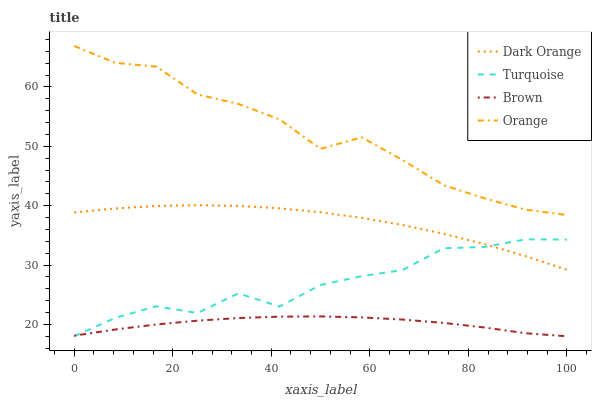Does Brown have the minimum area under the curve?
Answer yes or no. Yes. Does Orange have the maximum area under the curve?
Answer yes or no. Yes. Does Dark Orange have the minimum area under the curve?
Answer yes or no. No. Does Dark Orange have the maximum area under the curve?
Answer yes or no. No. Is Brown the smoothest?
Answer yes or no. Yes. Is Turquoise the roughest?
Answer yes or no. Yes. Is Dark Orange the smoothest?
Answer yes or no. No. Is Dark Orange the roughest?
Answer yes or no. No. Does Turquoise have the lowest value?
Answer yes or no. Yes. Does Dark Orange have the lowest value?
Answer yes or no. No. Does Orange have the highest value?
Answer yes or no. Yes. Does Dark Orange have the highest value?
Answer yes or no. No. Is Dark Orange less than Orange?
Answer yes or no. Yes. Is Orange greater than Brown?
Answer yes or no. Yes. Does Dark Orange intersect Turquoise?
Answer yes or no. Yes. Is Dark Orange less than Turquoise?
Answer yes or no. No. Is Dark Orange greater than Turquoise?
Answer yes or no. No. Does Dark Orange intersect Orange?
Answer yes or no. No. 